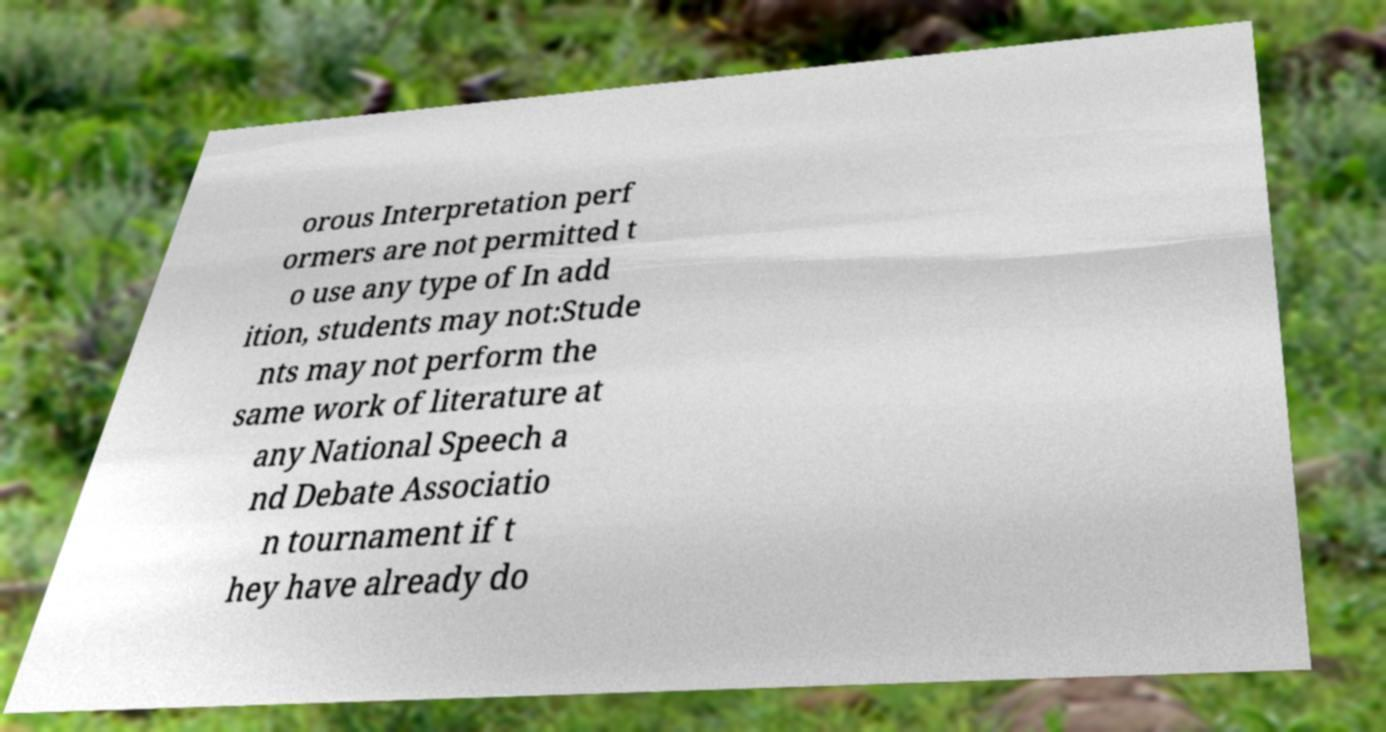Can you read and provide the text displayed in the image?This photo seems to have some interesting text. Can you extract and type it out for me? orous Interpretation perf ormers are not permitted t o use any type of In add ition, students may not:Stude nts may not perform the same work of literature at any National Speech a nd Debate Associatio n tournament if t hey have already do 